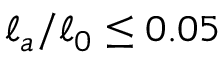<formula> <loc_0><loc_0><loc_500><loc_500>\ell _ { a } / \ell _ { 0 } \leq 0 . 0 5</formula> 